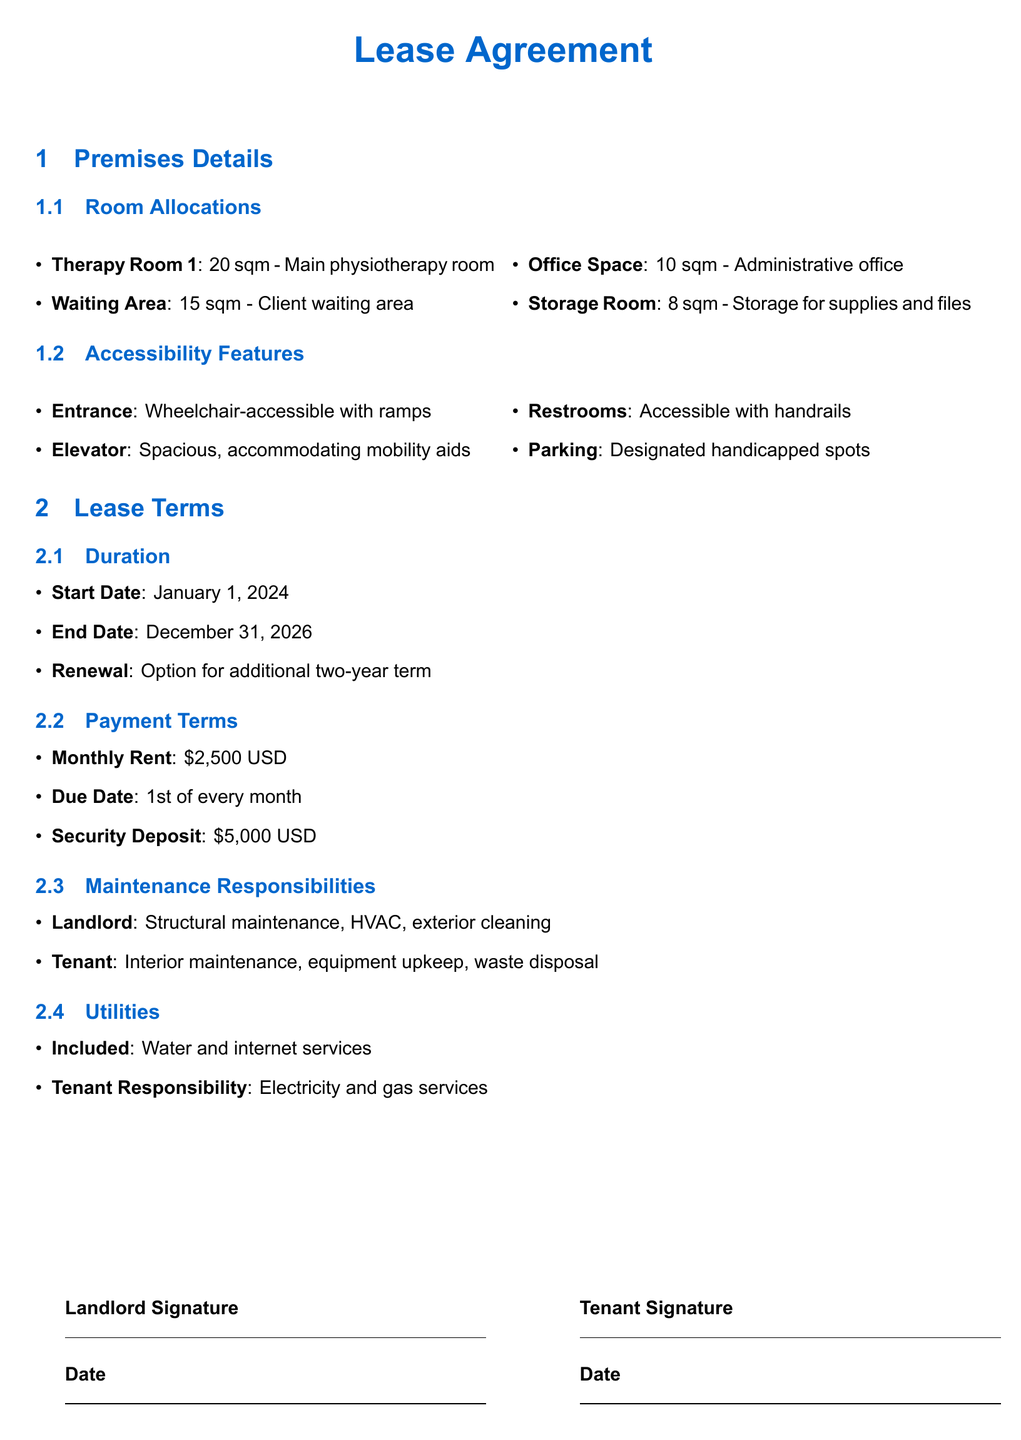What is the size of Therapy Room 1? Therapy Room 1 is specified in the document as having an area of 20 sqm.
Answer: 20 sqm What features make the entrance accessible? The document lists wheelchair-accessible with ramps as the features of the entrance.
Answer: Wheelchair-accessible with ramps When does the lease agreement start? The start date of the lease agreement is explicitly stated in the document.
Answer: January 1, 2024 What is the monthly rent for the premises? The document provides the amount for the monthly rent, which is mentioned clearly.
Answer: $2,500 USD What is the duration of the lease agreement? The lease agreement extends from the start date to the end date which is stated in the document.
Answer: Three years What is provided for tenant responsibility regarding utilities? The document mentions the specific utility that the tenant is responsible for.
Answer: Electricity and gas services Is there a parking feature for clients? The document highlights designated parking spots specifically designed for accessibility needs.
Answer: Designated handicapped spots What is the security deposit amount? The amount for the security deposit is explicitly stated in the lease terms.
Answer: $5,000 USD 